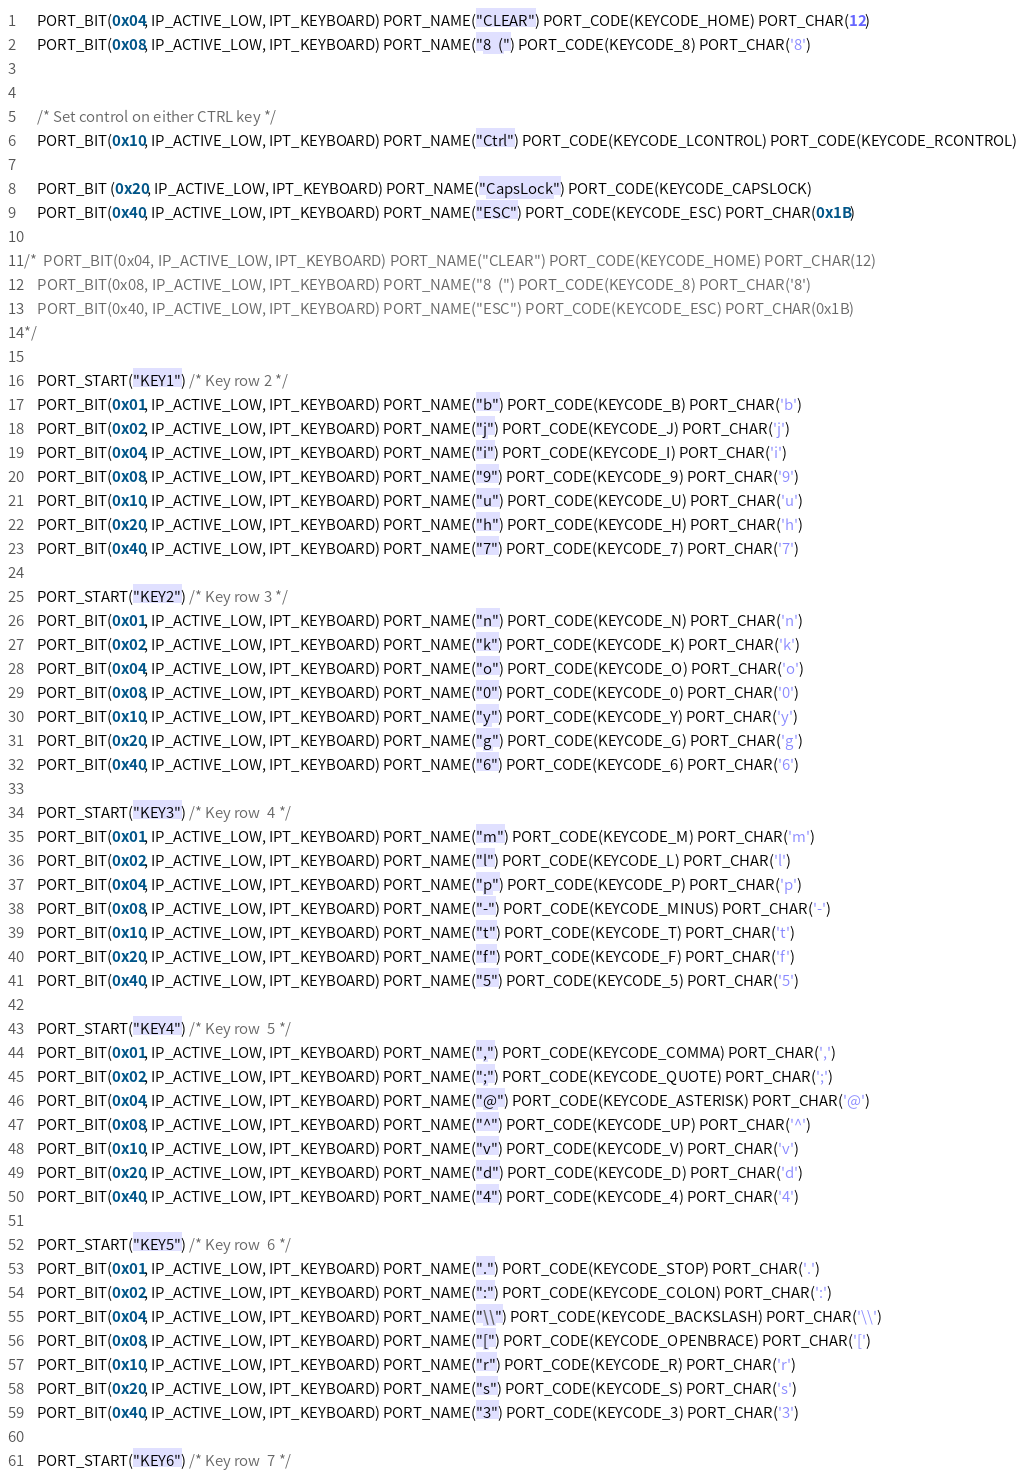Convert code to text. <code><loc_0><loc_0><loc_500><loc_500><_C++_>	PORT_BIT(0x04, IP_ACTIVE_LOW, IPT_KEYBOARD) PORT_NAME("CLEAR") PORT_CODE(KEYCODE_HOME) PORT_CHAR(12)
	PORT_BIT(0x08, IP_ACTIVE_LOW, IPT_KEYBOARD) PORT_NAME("8  (") PORT_CODE(KEYCODE_8) PORT_CHAR('8')


	/* Set control on either CTRL key */
	PORT_BIT(0x10, IP_ACTIVE_LOW, IPT_KEYBOARD) PORT_NAME("Ctrl") PORT_CODE(KEYCODE_LCONTROL) PORT_CODE(KEYCODE_RCONTROL)

	PORT_BIT (0x20, IP_ACTIVE_LOW, IPT_KEYBOARD) PORT_NAME("CapsLock") PORT_CODE(KEYCODE_CAPSLOCK)
	PORT_BIT(0x40, IP_ACTIVE_LOW, IPT_KEYBOARD) PORT_NAME("ESC") PORT_CODE(KEYCODE_ESC) PORT_CHAR(0x1B)

/*  PORT_BIT(0x04, IP_ACTIVE_LOW, IPT_KEYBOARD) PORT_NAME("CLEAR") PORT_CODE(KEYCODE_HOME) PORT_CHAR(12)
    PORT_BIT(0x08, IP_ACTIVE_LOW, IPT_KEYBOARD) PORT_NAME("8  (") PORT_CODE(KEYCODE_8) PORT_CHAR('8')
    PORT_BIT(0x40, IP_ACTIVE_LOW, IPT_KEYBOARD) PORT_NAME("ESC") PORT_CODE(KEYCODE_ESC) PORT_CHAR(0x1B)
*/

	PORT_START("KEY1") /* Key row 2 */
	PORT_BIT(0x01, IP_ACTIVE_LOW, IPT_KEYBOARD) PORT_NAME("b") PORT_CODE(KEYCODE_B) PORT_CHAR('b')
	PORT_BIT(0x02, IP_ACTIVE_LOW, IPT_KEYBOARD) PORT_NAME("j") PORT_CODE(KEYCODE_J) PORT_CHAR('j')
	PORT_BIT(0x04, IP_ACTIVE_LOW, IPT_KEYBOARD) PORT_NAME("i") PORT_CODE(KEYCODE_I) PORT_CHAR('i')
	PORT_BIT(0x08, IP_ACTIVE_LOW, IPT_KEYBOARD) PORT_NAME("9") PORT_CODE(KEYCODE_9) PORT_CHAR('9')
	PORT_BIT(0x10, IP_ACTIVE_LOW, IPT_KEYBOARD) PORT_NAME("u") PORT_CODE(KEYCODE_U) PORT_CHAR('u')
	PORT_BIT(0x20, IP_ACTIVE_LOW, IPT_KEYBOARD) PORT_NAME("h") PORT_CODE(KEYCODE_H) PORT_CHAR('h')
	PORT_BIT(0x40, IP_ACTIVE_LOW, IPT_KEYBOARD) PORT_NAME("7") PORT_CODE(KEYCODE_7) PORT_CHAR('7')

	PORT_START("KEY2") /* Key row 3 */
	PORT_BIT(0x01, IP_ACTIVE_LOW, IPT_KEYBOARD) PORT_NAME("n") PORT_CODE(KEYCODE_N) PORT_CHAR('n')
	PORT_BIT(0x02, IP_ACTIVE_LOW, IPT_KEYBOARD) PORT_NAME("k") PORT_CODE(KEYCODE_K) PORT_CHAR('k')
	PORT_BIT(0x04, IP_ACTIVE_LOW, IPT_KEYBOARD) PORT_NAME("o") PORT_CODE(KEYCODE_O) PORT_CHAR('o')
	PORT_BIT(0x08, IP_ACTIVE_LOW, IPT_KEYBOARD) PORT_NAME("0") PORT_CODE(KEYCODE_0) PORT_CHAR('0')
	PORT_BIT(0x10, IP_ACTIVE_LOW, IPT_KEYBOARD) PORT_NAME("y") PORT_CODE(KEYCODE_Y) PORT_CHAR('y')
	PORT_BIT(0x20, IP_ACTIVE_LOW, IPT_KEYBOARD) PORT_NAME("g") PORT_CODE(KEYCODE_G) PORT_CHAR('g')
	PORT_BIT(0x40, IP_ACTIVE_LOW, IPT_KEYBOARD) PORT_NAME("6") PORT_CODE(KEYCODE_6) PORT_CHAR('6')

	PORT_START("KEY3") /* Key row  4 */
	PORT_BIT(0x01, IP_ACTIVE_LOW, IPT_KEYBOARD) PORT_NAME("m") PORT_CODE(KEYCODE_M) PORT_CHAR('m')
	PORT_BIT(0x02, IP_ACTIVE_LOW, IPT_KEYBOARD) PORT_NAME("l") PORT_CODE(KEYCODE_L) PORT_CHAR('l')
	PORT_BIT(0x04, IP_ACTIVE_LOW, IPT_KEYBOARD) PORT_NAME("p") PORT_CODE(KEYCODE_P) PORT_CHAR('p')
	PORT_BIT(0x08, IP_ACTIVE_LOW, IPT_KEYBOARD) PORT_NAME("-") PORT_CODE(KEYCODE_MINUS) PORT_CHAR('-')
	PORT_BIT(0x10, IP_ACTIVE_LOW, IPT_KEYBOARD) PORT_NAME("t") PORT_CODE(KEYCODE_T) PORT_CHAR('t')
	PORT_BIT(0x20, IP_ACTIVE_LOW, IPT_KEYBOARD) PORT_NAME("f") PORT_CODE(KEYCODE_F) PORT_CHAR('f')
	PORT_BIT(0x40, IP_ACTIVE_LOW, IPT_KEYBOARD) PORT_NAME("5") PORT_CODE(KEYCODE_5) PORT_CHAR('5')

	PORT_START("KEY4") /* Key row  5 */
	PORT_BIT(0x01, IP_ACTIVE_LOW, IPT_KEYBOARD) PORT_NAME(",") PORT_CODE(KEYCODE_COMMA) PORT_CHAR(',')
	PORT_BIT(0x02, IP_ACTIVE_LOW, IPT_KEYBOARD) PORT_NAME(";") PORT_CODE(KEYCODE_QUOTE) PORT_CHAR(';')
	PORT_BIT(0x04, IP_ACTIVE_LOW, IPT_KEYBOARD) PORT_NAME("@") PORT_CODE(KEYCODE_ASTERISK) PORT_CHAR('@')
	PORT_BIT(0x08, IP_ACTIVE_LOW, IPT_KEYBOARD) PORT_NAME("^") PORT_CODE(KEYCODE_UP) PORT_CHAR('^')
	PORT_BIT(0x10, IP_ACTIVE_LOW, IPT_KEYBOARD) PORT_NAME("v") PORT_CODE(KEYCODE_V) PORT_CHAR('v')
	PORT_BIT(0x20, IP_ACTIVE_LOW, IPT_KEYBOARD) PORT_NAME("d") PORT_CODE(KEYCODE_D) PORT_CHAR('d')
	PORT_BIT(0x40, IP_ACTIVE_LOW, IPT_KEYBOARD) PORT_NAME("4") PORT_CODE(KEYCODE_4) PORT_CHAR('4')

	PORT_START("KEY5") /* Key row  6 */
	PORT_BIT(0x01, IP_ACTIVE_LOW, IPT_KEYBOARD) PORT_NAME(".") PORT_CODE(KEYCODE_STOP) PORT_CHAR('.')
	PORT_BIT(0x02, IP_ACTIVE_LOW, IPT_KEYBOARD) PORT_NAME(":") PORT_CODE(KEYCODE_COLON) PORT_CHAR(':')
	PORT_BIT(0x04, IP_ACTIVE_LOW, IPT_KEYBOARD) PORT_NAME("\\") PORT_CODE(KEYCODE_BACKSLASH) PORT_CHAR('\\')
	PORT_BIT(0x08, IP_ACTIVE_LOW, IPT_KEYBOARD) PORT_NAME("[") PORT_CODE(KEYCODE_OPENBRACE) PORT_CHAR('[')
	PORT_BIT(0x10, IP_ACTIVE_LOW, IPT_KEYBOARD) PORT_NAME("r") PORT_CODE(KEYCODE_R) PORT_CHAR('r')
	PORT_BIT(0x20, IP_ACTIVE_LOW, IPT_KEYBOARD) PORT_NAME("s") PORT_CODE(KEYCODE_S) PORT_CHAR('s')
	PORT_BIT(0x40, IP_ACTIVE_LOW, IPT_KEYBOARD) PORT_NAME("3") PORT_CODE(KEYCODE_3) PORT_CHAR('3')

	PORT_START("KEY6") /* Key row  7 */</code> 